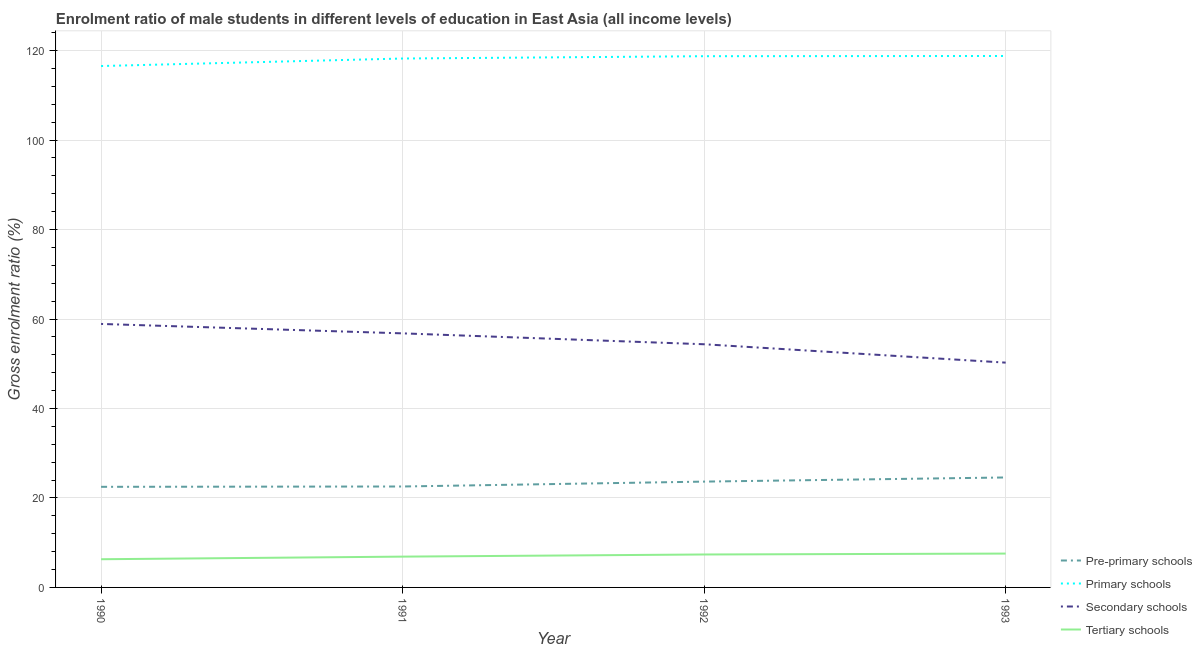Does the line corresponding to gross enrolment ratio(female) in secondary schools intersect with the line corresponding to gross enrolment ratio(female) in primary schools?
Your answer should be very brief. No. What is the gross enrolment ratio(female) in secondary schools in 1992?
Your answer should be compact. 54.36. Across all years, what is the maximum gross enrolment ratio(female) in tertiary schools?
Provide a succinct answer. 7.57. Across all years, what is the minimum gross enrolment ratio(female) in tertiary schools?
Offer a terse response. 6.3. In which year was the gross enrolment ratio(female) in primary schools minimum?
Provide a succinct answer. 1990. What is the total gross enrolment ratio(female) in pre-primary schools in the graph?
Keep it short and to the point. 93.29. What is the difference between the gross enrolment ratio(female) in tertiary schools in 1990 and that in 1993?
Offer a terse response. -1.26. What is the difference between the gross enrolment ratio(female) in primary schools in 1993 and the gross enrolment ratio(female) in tertiary schools in 1992?
Provide a succinct answer. 111.44. What is the average gross enrolment ratio(female) in pre-primary schools per year?
Your answer should be compact. 23.32. In the year 1990, what is the difference between the gross enrolment ratio(female) in pre-primary schools and gross enrolment ratio(female) in secondary schools?
Offer a terse response. -36.41. In how many years, is the gross enrolment ratio(female) in tertiary schools greater than 92 %?
Provide a succinct answer. 0. What is the ratio of the gross enrolment ratio(female) in secondary schools in 1991 to that in 1992?
Your answer should be very brief. 1.04. What is the difference between the highest and the second highest gross enrolment ratio(female) in primary schools?
Offer a terse response. 0.05. What is the difference between the highest and the lowest gross enrolment ratio(female) in pre-primary schools?
Keep it short and to the point. 2.09. Is it the case that in every year, the sum of the gross enrolment ratio(female) in pre-primary schools and gross enrolment ratio(female) in tertiary schools is greater than the sum of gross enrolment ratio(female) in secondary schools and gross enrolment ratio(female) in primary schools?
Offer a very short reply. No. What is the difference between two consecutive major ticks on the Y-axis?
Keep it short and to the point. 20. Does the graph contain grids?
Your answer should be very brief. Yes. Where does the legend appear in the graph?
Your answer should be compact. Bottom right. How are the legend labels stacked?
Provide a succinct answer. Vertical. What is the title of the graph?
Keep it short and to the point. Enrolment ratio of male students in different levels of education in East Asia (all income levels). Does "Bird species" appear as one of the legend labels in the graph?
Ensure brevity in your answer.  No. What is the label or title of the Y-axis?
Give a very brief answer. Gross enrolment ratio (%). What is the Gross enrolment ratio (%) in Pre-primary schools in 1990?
Make the answer very short. 22.49. What is the Gross enrolment ratio (%) in Primary schools in 1990?
Your answer should be very brief. 116.56. What is the Gross enrolment ratio (%) of Secondary schools in 1990?
Give a very brief answer. 58.9. What is the Gross enrolment ratio (%) in Tertiary schools in 1990?
Offer a terse response. 6.3. What is the Gross enrolment ratio (%) of Pre-primary schools in 1991?
Make the answer very short. 22.56. What is the Gross enrolment ratio (%) of Primary schools in 1991?
Ensure brevity in your answer.  118.24. What is the Gross enrolment ratio (%) in Secondary schools in 1991?
Your answer should be very brief. 56.8. What is the Gross enrolment ratio (%) of Tertiary schools in 1991?
Give a very brief answer. 6.89. What is the Gross enrolment ratio (%) in Pre-primary schools in 1992?
Your answer should be very brief. 23.66. What is the Gross enrolment ratio (%) of Primary schools in 1992?
Offer a terse response. 118.75. What is the Gross enrolment ratio (%) of Secondary schools in 1992?
Make the answer very short. 54.36. What is the Gross enrolment ratio (%) of Tertiary schools in 1992?
Provide a succinct answer. 7.36. What is the Gross enrolment ratio (%) of Pre-primary schools in 1993?
Offer a very short reply. 24.58. What is the Gross enrolment ratio (%) in Primary schools in 1993?
Make the answer very short. 118.8. What is the Gross enrolment ratio (%) in Secondary schools in 1993?
Provide a succinct answer. 50.25. What is the Gross enrolment ratio (%) in Tertiary schools in 1993?
Your answer should be compact. 7.57. Across all years, what is the maximum Gross enrolment ratio (%) in Pre-primary schools?
Provide a succinct answer. 24.58. Across all years, what is the maximum Gross enrolment ratio (%) in Primary schools?
Keep it short and to the point. 118.8. Across all years, what is the maximum Gross enrolment ratio (%) of Secondary schools?
Your answer should be compact. 58.9. Across all years, what is the maximum Gross enrolment ratio (%) in Tertiary schools?
Your answer should be very brief. 7.57. Across all years, what is the minimum Gross enrolment ratio (%) of Pre-primary schools?
Provide a short and direct response. 22.49. Across all years, what is the minimum Gross enrolment ratio (%) in Primary schools?
Provide a succinct answer. 116.56. Across all years, what is the minimum Gross enrolment ratio (%) in Secondary schools?
Give a very brief answer. 50.25. Across all years, what is the minimum Gross enrolment ratio (%) of Tertiary schools?
Make the answer very short. 6.3. What is the total Gross enrolment ratio (%) in Pre-primary schools in the graph?
Your answer should be compact. 93.29. What is the total Gross enrolment ratio (%) in Primary schools in the graph?
Offer a very short reply. 472.35. What is the total Gross enrolment ratio (%) in Secondary schools in the graph?
Provide a short and direct response. 220.31. What is the total Gross enrolment ratio (%) of Tertiary schools in the graph?
Keep it short and to the point. 28.12. What is the difference between the Gross enrolment ratio (%) in Pre-primary schools in 1990 and that in 1991?
Ensure brevity in your answer.  -0.07. What is the difference between the Gross enrolment ratio (%) in Primary schools in 1990 and that in 1991?
Offer a terse response. -1.68. What is the difference between the Gross enrolment ratio (%) of Secondary schools in 1990 and that in 1991?
Your response must be concise. 2.11. What is the difference between the Gross enrolment ratio (%) of Tertiary schools in 1990 and that in 1991?
Ensure brevity in your answer.  -0.58. What is the difference between the Gross enrolment ratio (%) in Pre-primary schools in 1990 and that in 1992?
Give a very brief answer. -1.17. What is the difference between the Gross enrolment ratio (%) of Primary schools in 1990 and that in 1992?
Your answer should be compact. -2.2. What is the difference between the Gross enrolment ratio (%) in Secondary schools in 1990 and that in 1992?
Offer a terse response. 4.54. What is the difference between the Gross enrolment ratio (%) in Tertiary schools in 1990 and that in 1992?
Offer a terse response. -1.06. What is the difference between the Gross enrolment ratio (%) of Pre-primary schools in 1990 and that in 1993?
Give a very brief answer. -2.09. What is the difference between the Gross enrolment ratio (%) in Primary schools in 1990 and that in 1993?
Offer a terse response. -2.25. What is the difference between the Gross enrolment ratio (%) in Secondary schools in 1990 and that in 1993?
Offer a very short reply. 8.65. What is the difference between the Gross enrolment ratio (%) of Tertiary schools in 1990 and that in 1993?
Ensure brevity in your answer.  -1.26. What is the difference between the Gross enrolment ratio (%) of Pre-primary schools in 1991 and that in 1992?
Provide a short and direct response. -1.09. What is the difference between the Gross enrolment ratio (%) in Primary schools in 1991 and that in 1992?
Provide a succinct answer. -0.52. What is the difference between the Gross enrolment ratio (%) of Secondary schools in 1991 and that in 1992?
Your response must be concise. 2.44. What is the difference between the Gross enrolment ratio (%) in Tertiary schools in 1991 and that in 1992?
Keep it short and to the point. -0.48. What is the difference between the Gross enrolment ratio (%) of Pre-primary schools in 1991 and that in 1993?
Your answer should be compact. -2.02. What is the difference between the Gross enrolment ratio (%) in Primary schools in 1991 and that in 1993?
Provide a short and direct response. -0.57. What is the difference between the Gross enrolment ratio (%) in Secondary schools in 1991 and that in 1993?
Offer a very short reply. 6.54. What is the difference between the Gross enrolment ratio (%) of Tertiary schools in 1991 and that in 1993?
Offer a terse response. -0.68. What is the difference between the Gross enrolment ratio (%) of Pre-primary schools in 1992 and that in 1993?
Your response must be concise. -0.93. What is the difference between the Gross enrolment ratio (%) in Primary schools in 1992 and that in 1993?
Offer a very short reply. -0.05. What is the difference between the Gross enrolment ratio (%) in Secondary schools in 1992 and that in 1993?
Give a very brief answer. 4.11. What is the difference between the Gross enrolment ratio (%) in Tertiary schools in 1992 and that in 1993?
Your answer should be compact. -0.2. What is the difference between the Gross enrolment ratio (%) in Pre-primary schools in 1990 and the Gross enrolment ratio (%) in Primary schools in 1991?
Give a very brief answer. -95.75. What is the difference between the Gross enrolment ratio (%) in Pre-primary schools in 1990 and the Gross enrolment ratio (%) in Secondary schools in 1991?
Your answer should be compact. -34.31. What is the difference between the Gross enrolment ratio (%) of Pre-primary schools in 1990 and the Gross enrolment ratio (%) of Tertiary schools in 1991?
Ensure brevity in your answer.  15.6. What is the difference between the Gross enrolment ratio (%) of Primary schools in 1990 and the Gross enrolment ratio (%) of Secondary schools in 1991?
Your answer should be very brief. 59.76. What is the difference between the Gross enrolment ratio (%) in Primary schools in 1990 and the Gross enrolment ratio (%) in Tertiary schools in 1991?
Your answer should be compact. 109.67. What is the difference between the Gross enrolment ratio (%) of Secondary schools in 1990 and the Gross enrolment ratio (%) of Tertiary schools in 1991?
Offer a very short reply. 52.02. What is the difference between the Gross enrolment ratio (%) of Pre-primary schools in 1990 and the Gross enrolment ratio (%) of Primary schools in 1992?
Ensure brevity in your answer.  -96.26. What is the difference between the Gross enrolment ratio (%) of Pre-primary schools in 1990 and the Gross enrolment ratio (%) of Secondary schools in 1992?
Your response must be concise. -31.87. What is the difference between the Gross enrolment ratio (%) in Pre-primary schools in 1990 and the Gross enrolment ratio (%) in Tertiary schools in 1992?
Keep it short and to the point. 15.13. What is the difference between the Gross enrolment ratio (%) in Primary schools in 1990 and the Gross enrolment ratio (%) in Secondary schools in 1992?
Provide a succinct answer. 62.2. What is the difference between the Gross enrolment ratio (%) in Primary schools in 1990 and the Gross enrolment ratio (%) in Tertiary schools in 1992?
Your answer should be compact. 109.19. What is the difference between the Gross enrolment ratio (%) in Secondary schools in 1990 and the Gross enrolment ratio (%) in Tertiary schools in 1992?
Your answer should be compact. 51.54. What is the difference between the Gross enrolment ratio (%) of Pre-primary schools in 1990 and the Gross enrolment ratio (%) of Primary schools in 1993?
Provide a succinct answer. -96.31. What is the difference between the Gross enrolment ratio (%) in Pre-primary schools in 1990 and the Gross enrolment ratio (%) in Secondary schools in 1993?
Offer a very short reply. -27.76. What is the difference between the Gross enrolment ratio (%) of Pre-primary schools in 1990 and the Gross enrolment ratio (%) of Tertiary schools in 1993?
Give a very brief answer. 14.92. What is the difference between the Gross enrolment ratio (%) in Primary schools in 1990 and the Gross enrolment ratio (%) in Secondary schools in 1993?
Offer a very short reply. 66.3. What is the difference between the Gross enrolment ratio (%) of Primary schools in 1990 and the Gross enrolment ratio (%) of Tertiary schools in 1993?
Give a very brief answer. 108.99. What is the difference between the Gross enrolment ratio (%) in Secondary schools in 1990 and the Gross enrolment ratio (%) in Tertiary schools in 1993?
Give a very brief answer. 51.34. What is the difference between the Gross enrolment ratio (%) in Pre-primary schools in 1991 and the Gross enrolment ratio (%) in Primary schools in 1992?
Offer a very short reply. -96.19. What is the difference between the Gross enrolment ratio (%) of Pre-primary schools in 1991 and the Gross enrolment ratio (%) of Secondary schools in 1992?
Keep it short and to the point. -31.8. What is the difference between the Gross enrolment ratio (%) in Pre-primary schools in 1991 and the Gross enrolment ratio (%) in Tertiary schools in 1992?
Provide a short and direct response. 15.2. What is the difference between the Gross enrolment ratio (%) in Primary schools in 1991 and the Gross enrolment ratio (%) in Secondary schools in 1992?
Ensure brevity in your answer.  63.88. What is the difference between the Gross enrolment ratio (%) in Primary schools in 1991 and the Gross enrolment ratio (%) in Tertiary schools in 1992?
Make the answer very short. 110.87. What is the difference between the Gross enrolment ratio (%) in Secondary schools in 1991 and the Gross enrolment ratio (%) in Tertiary schools in 1992?
Provide a short and direct response. 49.43. What is the difference between the Gross enrolment ratio (%) of Pre-primary schools in 1991 and the Gross enrolment ratio (%) of Primary schools in 1993?
Your answer should be compact. -96.24. What is the difference between the Gross enrolment ratio (%) in Pre-primary schools in 1991 and the Gross enrolment ratio (%) in Secondary schools in 1993?
Ensure brevity in your answer.  -27.69. What is the difference between the Gross enrolment ratio (%) of Pre-primary schools in 1991 and the Gross enrolment ratio (%) of Tertiary schools in 1993?
Your answer should be compact. 15. What is the difference between the Gross enrolment ratio (%) in Primary schools in 1991 and the Gross enrolment ratio (%) in Secondary schools in 1993?
Give a very brief answer. 67.98. What is the difference between the Gross enrolment ratio (%) in Primary schools in 1991 and the Gross enrolment ratio (%) in Tertiary schools in 1993?
Keep it short and to the point. 110.67. What is the difference between the Gross enrolment ratio (%) in Secondary schools in 1991 and the Gross enrolment ratio (%) in Tertiary schools in 1993?
Offer a very short reply. 49.23. What is the difference between the Gross enrolment ratio (%) of Pre-primary schools in 1992 and the Gross enrolment ratio (%) of Primary schools in 1993?
Provide a short and direct response. -95.15. What is the difference between the Gross enrolment ratio (%) in Pre-primary schools in 1992 and the Gross enrolment ratio (%) in Secondary schools in 1993?
Your response must be concise. -26.6. What is the difference between the Gross enrolment ratio (%) of Pre-primary schools in 1992 and the Gross enrolment ratio (%) of Tertiary schools in 1993?
Offer a terse response. 16.09. What is the difference between the Gross enrolment ratio (%) in Primary schools in 1992 and the Gross enrolment ratio (%) in Secondary schools in 1993?
Your answer should be compact. 68.5. What is the difference between the Gross enrolment ratio (%) of Primary schools in 1992 and the Gross enrolment ratio (%) of Tertiary schools in 1993?
Provide a short and direct response. 111.19. What is the difference between the Gross enrolment ratio (%) of Secondary schools in 1992 and the Gross enrolment ratio (%) of Tertiary schools in 1993?
Give a very brief answer. 46.79. What is the average Gross enrolment ratio (%) in Pre-primary schools per year?
Offer a very short reply. 23.32. What is the average Gross enrolment ratio (%) in Primary schools per year?
Your answer should be very brief. 118.09. What is the average Gross enrolment ratio (%) in Secondary schools per year?
Provide a succinct answer. 55.08. What is the average Gross enrolment ratio (%) in Tertiary schools per year?
Offer a terse response. 7.03. In the year 1990, what is the difference between the Gross enrolment ratio (%) of Pre-primary schools and Gross enrolment ratio (%) of Primary schools?
Give a very brief answer. -94.07. In the year 1990, what is the difference between the Gross enrolment ratio (%) of Pre-primary schools and Gross enrolment ratio (%) of Secondary schools?
Keep it short and to the point. -36.41. In the year 1990, what is the difference between the Gross enrolment ratio (%) of Pre-primary schools and Gross enrolment ratio (%) of Tertiary schools?
Keep it short and to the point. 16.19. In the year 1990, what is the difference between the Gross enrolment ratio (%) in Primary schools and Gross enrolment ratio (%) in Secondary schools?
Ensure brevity in your answer.  57.65. In the year 1990, what is the difference between the Gross enrolment ratio (%) of Primary schools and Gross enrolment ratio (%) of Tertiary schools?
Your response must be concise. 110.25. In the year 1990, what is the difference between the Gross enrolment ratio (%) of Secondary schools and Gross enrolment ratio (%) of Tertiary schools?
Your response must be concise. 52.6. In the year 1991, what is the difference between the Gross enrolment ratio (%) of Pre-primary schools and Gross enrolment ratio (%) of Primary schools?
Your response must be concise. -95.67. In the year 1991, what is the difference between the Gross enrolment ratio (%) in Pre-primary schools and Gross enrolment ratio (%) in Secondary schools?
Offer a very short reply. -34.23. In the year 1991, what is the difference between the Gross enrolment ratio (%) in Pre-primary schools and Gross enrolment ratio (%) in Tertiary schools?
Provide a succinct answer. 15.68. In the year 1991, what is the difference between the Gross enrolment ratio (%) of Primary schools and Gross enrolment ratio (%) of Secondary schools?
Provide a short and direct response. 61.44. In the year 1991, what is the difference between the Gross enrolment ratio (%) of Primary schools and Gross enrolment ratio (%) of Tertiary schools?
Your response must be concise. 111.35. In the year 1991, what is the difference between the Gross enrolment ratio (%) of Secondary schools and Gross enrolment ratio (%) of Tertiary schools?
Make the answer very short. 49.91. In the year 1992, what is the difference between the Gross enrolment ratio (%) of Pre-primary schools and Gross enrolment ratio (%) of Primary schools?
Your answer should be compact. -95.1. In the year 1992, what is the difference between the Gross enrolment ratio (%) in Pre-primary schools and Gross enrolment ratio (%) in Secondary schools?
Provide a succinct answer. -30.7. In the year 1992, what is the difference between the Gross enrolment ratio (%) of Pre-primary schools and Gross enrolment ratio (%) of Tertiary schools?
Your answer should be compact. 16.29. In the year 1992, what is the difference between the Gross enrolment ratio (%) in Primary schools and Gross enrolment ratio (%) in Secondary schools?
Offer a very short reply. 64.39. In the year 1992, what is the difference between the Gross enrolment ratio (%) in Primary schools and Gross enrolment ratio (%) in Tertiary schools?
Make the answer very short. 111.39. In the year 1992, what is the difference between the Gross enrolment ratio (%) in Secondary schools and Gross enrolment ratio (%) in Tertiary schools?
Give a very brief answer. 46.99. In the year 1993, what is the difference between the Gross enrolment ratio (%) of Pre-primary schools and Gross enrolment ratio (%) of Primary schools?
Make the answer very short. -94.22. In the year 1993, what is the difference between the Gross enrolment ratio (%) in Pre-primary schools and Gross enrolment ratio (%) in Secondary schools?
Your answer should be very brief. -25.67. In the year 1993, what is the difference between the Gross enrolment ratio (%) in Pre-primary schools and Gross enrolment ratio (%) in Tertiary schools?
Offer a terse response. 17.02. In the year 1993, what is the difference between the Gross enrolment ratio (%) in Primary schools and Gross enrolment ratio (%) in Secondary schools?
Your response must be concise. 68.55. In the year 1993, what is the difference between the Gross enrolment ratio (%) of Primary schools and Gross enrolment ratio (%) of Tertiary schools?
Provide a short and direct response. 111.24. In the year 1993, what is the difference between the Gross enrolment ratio (%) in Secondary schools and Gross enrolment ratio (%) in Tertiary schools?
Keep it short and to the point. 42.69. What is the ratio of the Gross enrolment ratio (%) of Pre-primary schools in 1990 to that in 1991?
Your response must be concise. 1. What is the ratio of the Gross enrolment ratio (%) in Primary schools in 1990 to that in 1991?
Ensure brevity in your answer.  0.99. What is the ratio of the Gross enrolment ratio (%) of Secondary schools in 1990 to that in 1991?
Provide a succinct answer. 1.04. What is the ratio of the Gross enrolment ratio (%) of Tertiary schools in 1990 to that in 1991?
Make the answer very short. 0.92. What is the ratio of the Gross enrolment ratio (%) of Pre-primary schools in 1990 to that in 1992?
Offer a terse response. 0.95. What is the ratio of the Gross enrolment ratio (%) in Primary schools in 1990 to that in 1992?
Your response must be concise. 0.98. What is the ratio of the Gross enrolment ratio (%) of Secondary schools in 1990 to that in 1992?
Your answer should be very brief. 1.08. What is the ratio of the Gross enrolment ratio (%) of Tertiary schools in 1990 to that in 1992?
Make the answer very short. 0.86. What is the ratio of the Gross enrolment ratio (%) of Pre-primary schools in 1990 to that in 1993?
Offer a very short reply. 0.91. What is the ratio of the Gross enrolment ratio (%) of Primary schools in 1990 to that in 1993?
Ensure brevity in your answer.  0.98. What is the ratio of the Gross enrolment ratio (%) of Secondary schools in 1990 to that in 1993?
Make the answer very short. 1.17. What is the ratio of the Gross enrolment ratio (%) in Tertiary schools in 1990 to that in 1993?
Provide a succinct answer. 0.83. What is the ratio of the Gross enrolment ratio (%) in Pre-primary schools in 1991 to that in 1992?
Give a very brief answer. 0.95. What is the ratio of the Gross enrolment ratio (%) in Primary schools in 1991 to that in 1992?
Your response must be concise. 1. What is the ratio of the Gross enrolment ratio (%) of Secondary schools in 1991 to that in 1992?
Provide a succinct answer. 1.04. What is the ratio of the Gross enrolment ratio (%) in Tertiary schools in 1991 to that in 1992?
Ensure brevity in your answer.  0.94. What is the ratio of the Gross enrolment ratio (%) in Pre-primary schools in 1991 to that in 1993?
Make the answer very short. 0.92. What is the ratio of the Gross enrolment ratio (%) in Secondary schools in 1991 to that in 1993?
Your answer should be compact. 1.13. What is the ratio of the Gross enrolment ratio (%) in Tertiary schools in 1991 to that in 1993?
Make the answer very short. 0.91. What is the ratio of the Gross enrolment ratio (%) in Pre-primary schools in 1992 to that in 1993?
Offer a very short reply. 0.96. What is the ratio of the Gross enrolment ratio (%) of Secondary schools in 1992 to that in 1993?
Your answer should be very brief. 1.08. What is the ratio of the Gross enrolment ratio (%) of Tertiary schools in 1992 to that in 1993?
Your answer should be compact. 0.97. What is the difference between the highest and the second highest Gross enrolment ratio (%) in Pre-primary schools?
Provide a short and direct response. 0.93. What is the difference between the highest and the second highest Gross enrolment ratio (%) of Primary schools?
Make the answer very short. 0.05. What is the difference between the highest and the second highest Gross enrolment ratio (%) in Secondary schools?
Offer a very short reply. 2.11. What is the difference between the highest and the second highest Gross enrolment ratio (%) of Tertiary schools?
Offer a terse response. 0.2. What is the difference between the highest and the lowest Gross enrolment ratio (%) of Pre-primary schools?
Make the answer very short. 2.09. What is the difference between the highest and the lowest Gross enrolment ratio (%) of Primary schools?
Provide a short and direct response. 2.25. What is the difference between the highest and the lowest Gross enrolment ratio (%) in Secondary schools?
Ensure brevity in your answer.  8.65. What is the difference between the highest and the lowest Gross enrolment ratio (%) of Tertiary schools?
Offer a very short reply. 1.26. 